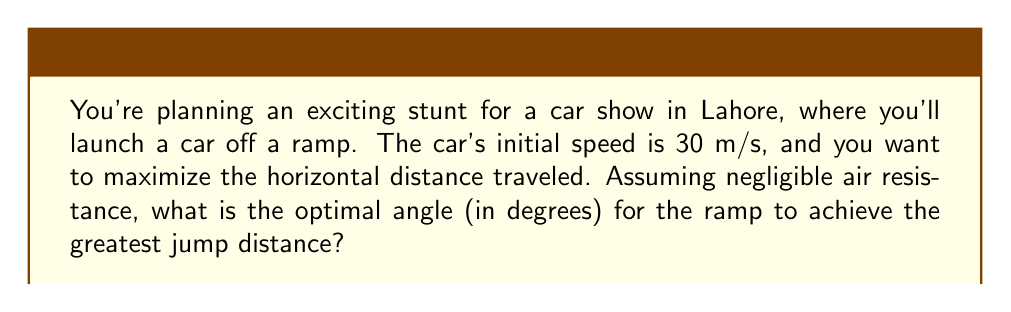Can you answer this question? To solve this problem, we'll use concepts from projectile motion in calculus. Let's approach this step-by-step:

1) In projectile motion, the horizontal distance (R) traveled is given by:

   $$R = \frac{v^2 \sin(2\theta)}{g}$$

   Where:
   $v$ is the initial velocity
   $\theta$ is the launch angle
   $g$ is the acceleration due to gravity (9.8 m/s²)

2) To find the maximum distance, we need to find the angle $\theta$ that maximizes this function. We can do this by taking the derivative of R with respect to $\theta$ and setting it to zero:

   $$\frac{dR}{d\theta} = \frac{2v^2 \cos(2\theta)}{g} = 0$$

3) Solving this equation:
   $$\cos(2\theta) = 0$$
   $$2\theta = 90°$$
   $$\theta = 45°$$

4) The second derivative is negative at $\theta = 45°$, confirming this is indeed a maximum.

5) Therefore, the optimal angle for maximum distance is 45°, regardless of the initial velocity or gravity.

6) We don't need to use the given initial velocity (30 m/s) to find the optimal angle, but we could use it to calculate the actual jump distance if needed.
Answer: 45° 